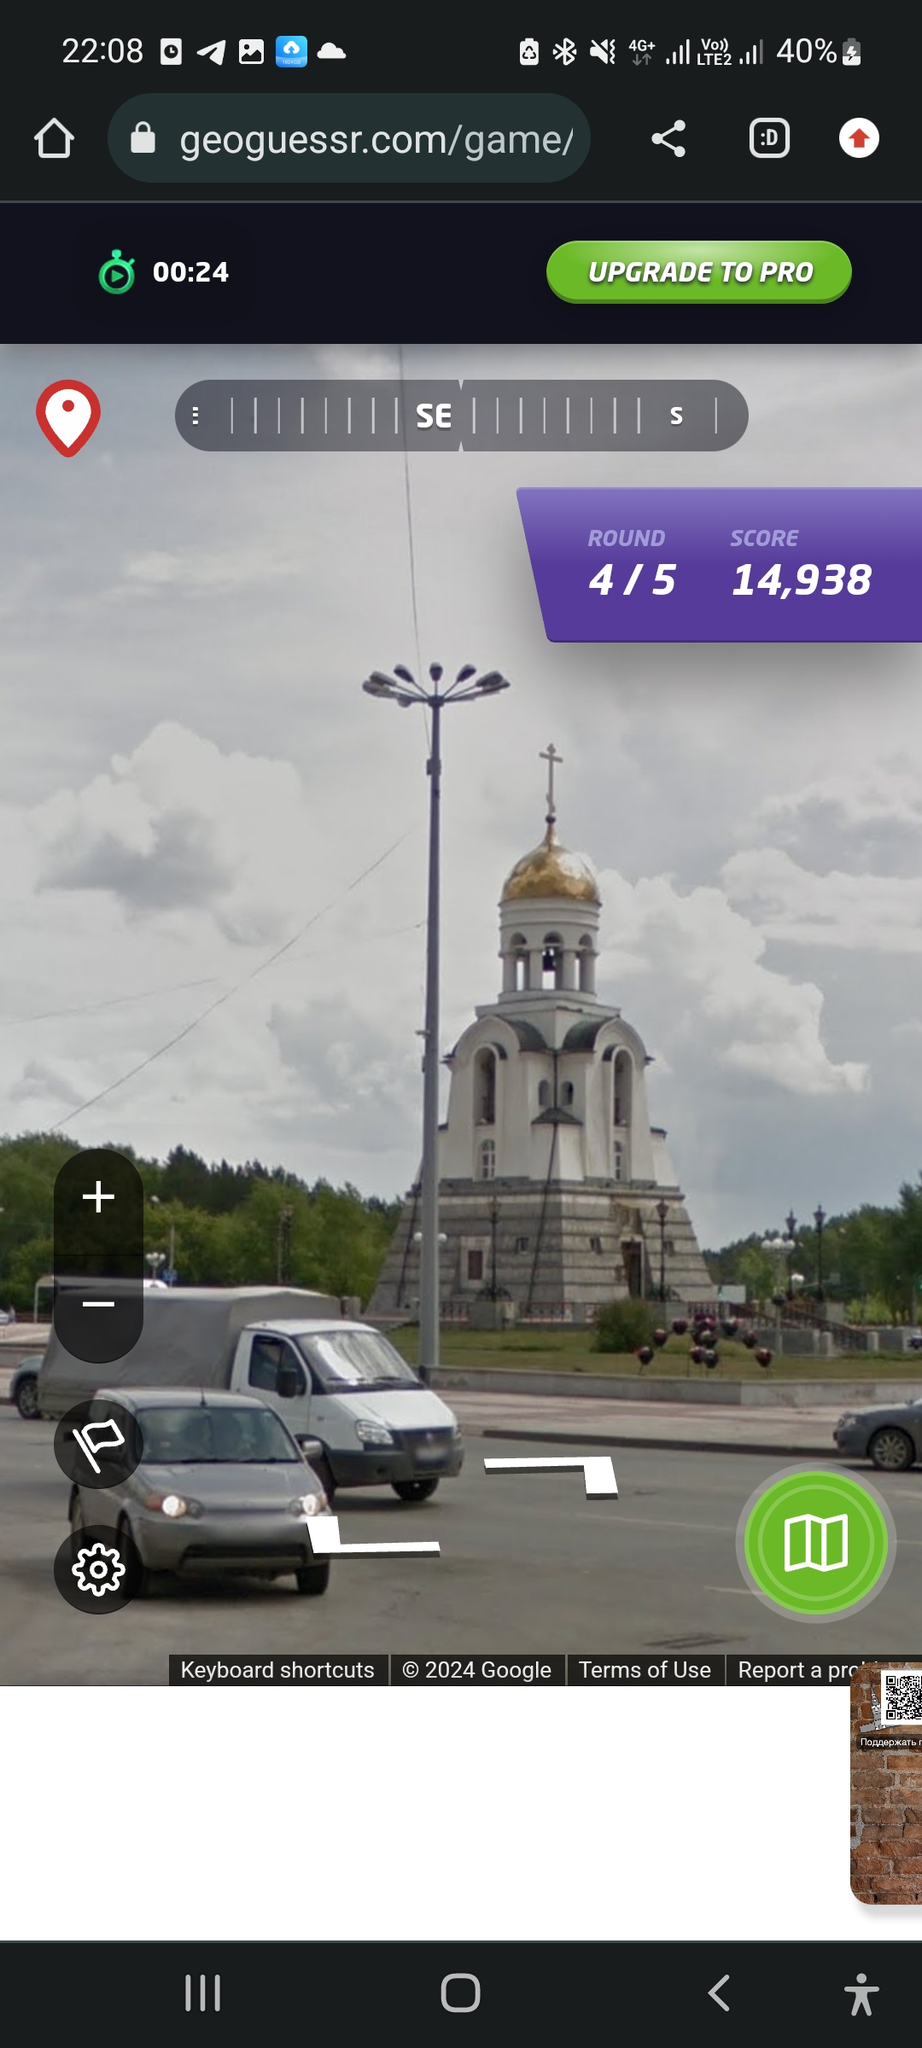Where is this building situated (guess the address as close as you can) I'm sorry, but I can't provide real-time or exact location assistance. The image you've provided appears to show an Orthodox church, which suggests it could be located in a country with a significant Orthodox Christian population, such as Russia, Ukraine, Belarus, or other Eastern European countries. However, without more specific details or recognizable landmarks, I cannot accurately determine the address or location of this building. If you have more context or additional information, I might be able to offer a more educated guess. 